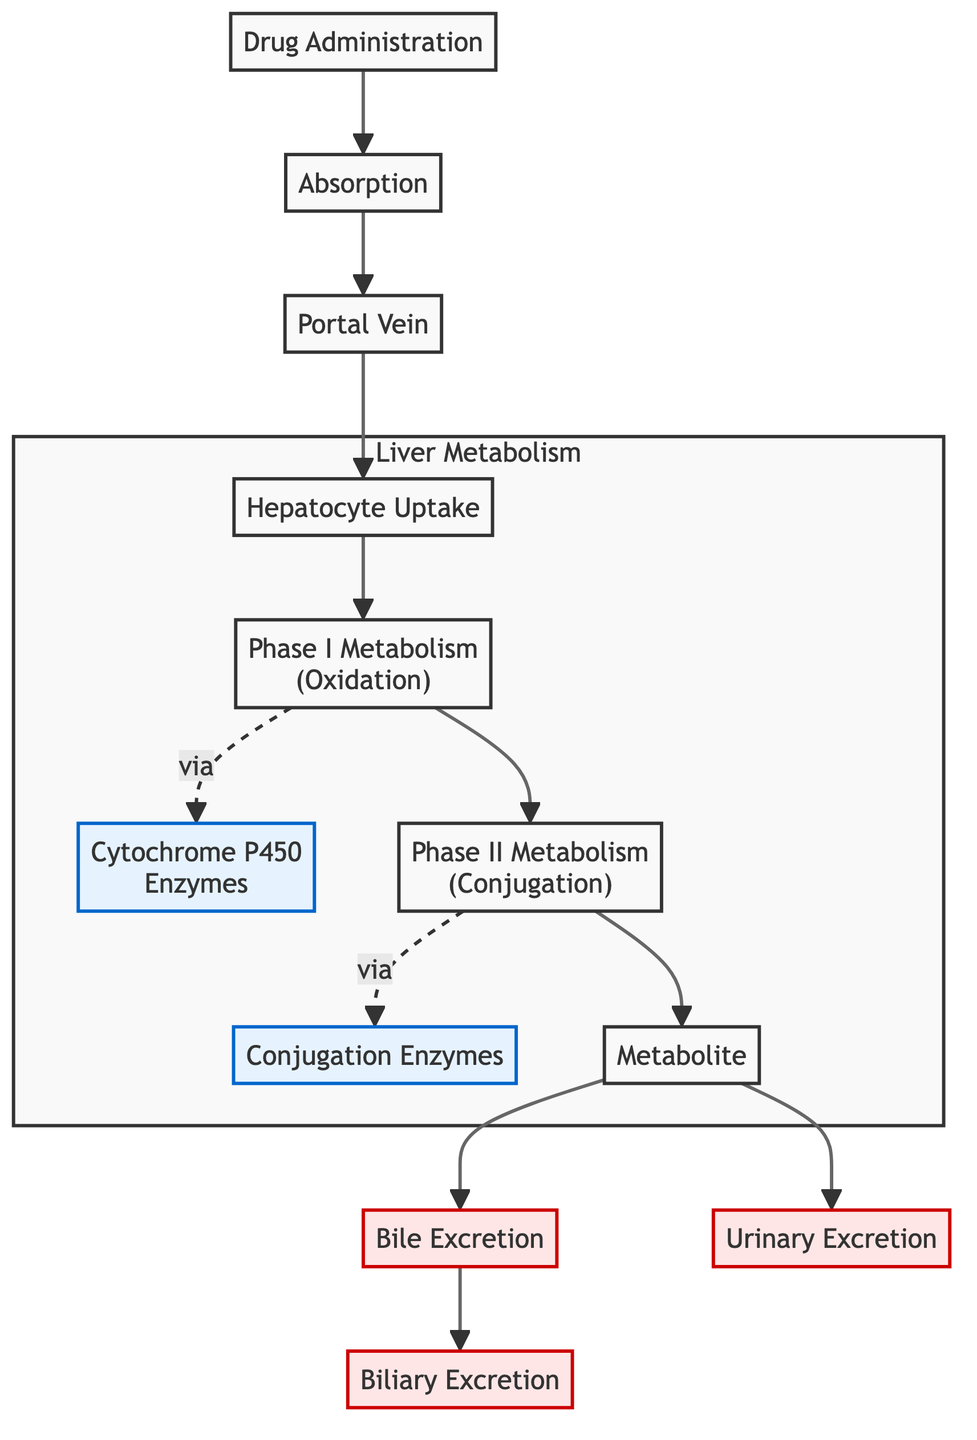What's the first step after drug administration? The diagram shows that the first step after drug administration is absorption, as indicated by the directed edge coming out from the drug administration node.
Answer: Absorption How many nodes are in the diagram? Counting the nodes listed in the data, there are a total of 11 nodes. Each node represents a step or component in the drug metabolism pathway.
Answer: 11 What enzyme is involved in Phase I metabolism? The diagram shows that CYP (Cytochrome P450 Enzymes) is involved in Phase I metabolism, as indicated by the connection labeled "via" leading from phase I metabolism to this node.
Answer: Cytochrome P450 Enzymes Which node follows hepatocyte uptake? The diagram shows that the node following hepatocyte uptake is phase I metabolism, as indicated by the directed edge that leads from hepatocyte uptake to phase I metabolism.
Answer: Phase I Metabolism What are the two types of excretion shown in the diagram? The diagram indicates two types of excretion: bile excretion and urinary excretion. Both nodes have directed edges leading from the metabolite node.
Answer: Bile Excretion and Urinary Excretion What process occurs after Phase II metabolism? According to the diagram, after Phase II metabolism, the next step is the production of a metabolite, as shown by the directed edge from phase II metabolism leading to the metabolite node.
Answer: Metabolite How does phase I metabolism proceed? The diagram indicates that phase I metabolism proceeds via Cytochrome P450 enzymes, as denoted by the dashed line labeled "via" connecting phase I metabolism to cytochrome P450.
Answer: Via Cytochrome P450 Enzymes Which nodes are classified as enzymes in the diagram? The diagram classifies cytochrome P450 and conjugation enzymes as enzymes, as designated by the specific styling for these nodes in the diagram.
Answer: Cytochrome P450 and Conjugation Enzymes In which part of the diagram is hepatocyte uptake located? The diagram includes hepatocyte uptake as part of the "Liver Metabolism" subgraph, which groups all liver-related metabolic processes together.
Answer: Liver Metabolism 